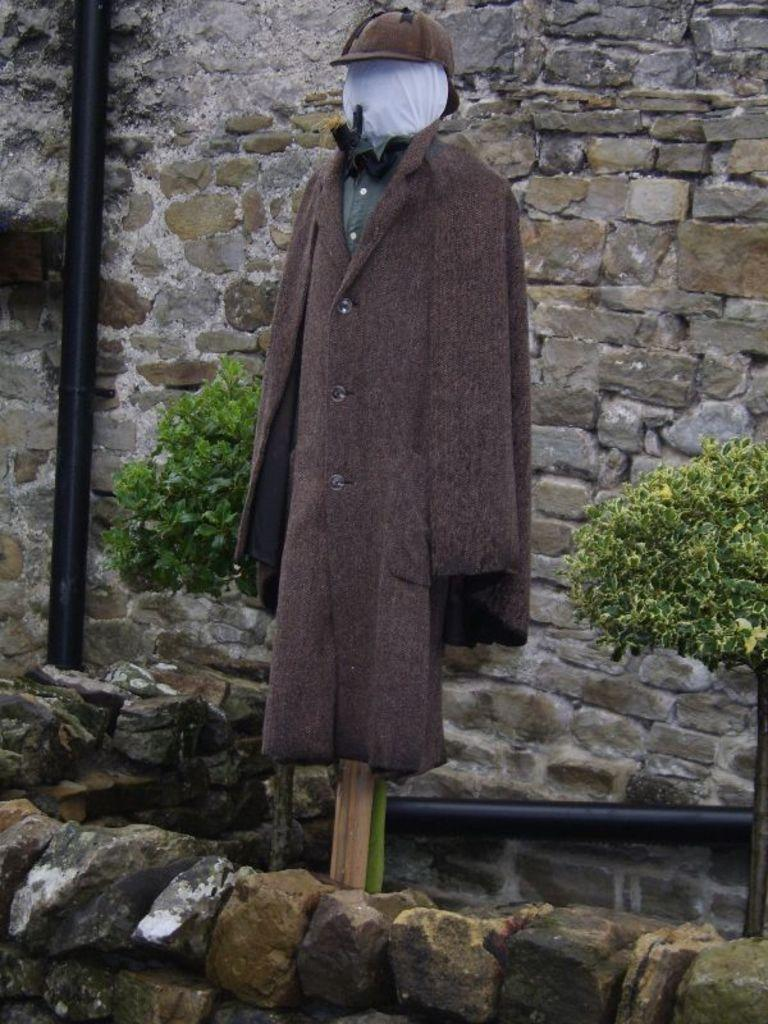What is located at the bottom of the image? There are stones at the bottom of the image. What is in the middle of the image? There is a cloth and a cap in the middle of the image. What type of vegetation can be seen in the image? There are plants visible in the image. What is visible in the background of the image? There is a wall in the background of the image. How many straws are present in the image? There is no straw present in the image. Can you describe the ladybug's pattern on the cloth in the image? There is no ladybug present in the image. 